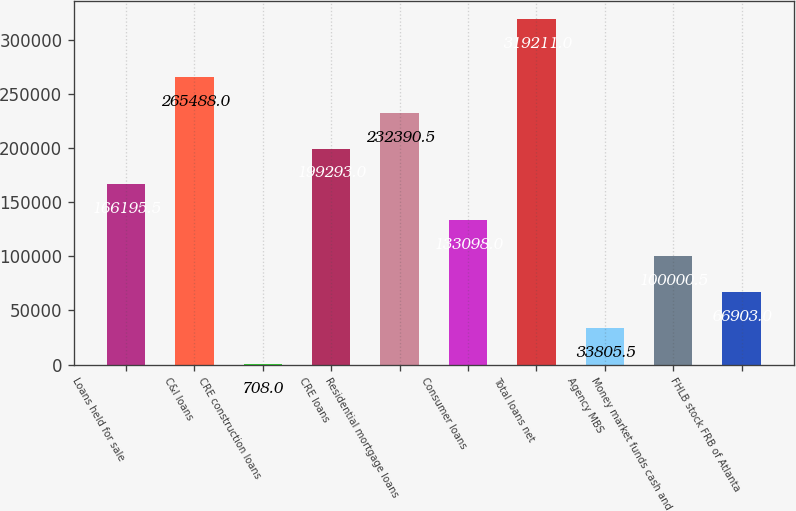<chart> <loc_0><loc_0><loc_500><loc_500><bar_chart><fcel>Loans held for sale<fcel>C&I loans<fcel>CRE construction loans<fcel>CRE loans<fcel>Residential mortgage loans<fcel>Consumer loans<fcel>Total loans net<fcel>Agency MBS<fcel>Money market funds cash and<fcel>FHLB stock FRB of Atlanta<nl><fcel>166196<fcel>265488<fcel>708<fcel>199293<fcel>232390<fcel>133098<fcel>319211<fcel>33805.5<fcel>100000<fcel>66903<nl></chart> 